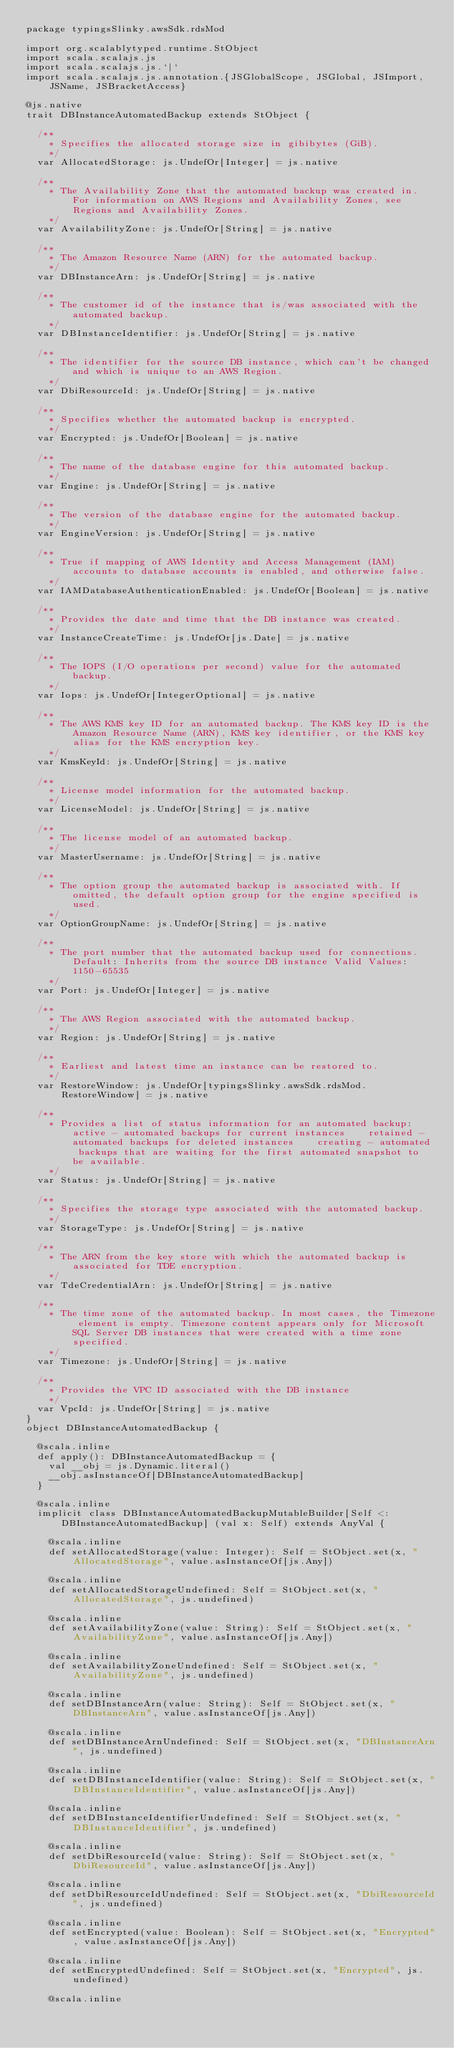<code> <loc_0><loc_0><loc_500><loc_500><_Scala_>package typingsSlinky.awsSdk.rdsMod

import org.scalablytyped.runtime.StObject
import scala.scalajs.js
import scala.scalajs.js.`|`
import scala.scalajs.js.annotation.{JSGlobalScope, JSGlobal, JSImport, JSName, JSBracketAccess}

@js.native
trait DBInstanceAutomatedBackup extends StObject {
  
  /**
    * Specifies the allocated storage size in gibibytes (GiB).
    */
  var AllocatedStorage: js.UndefOr[Integer] = js.native
  
  /**
    * The Availability Zone that the automated backup was created in. For information on AWS Regions and Availability Zones, see Regions and Availability Zones.
    */
  var AvailabilityZone: js.UndefOr[String] = js.native
  
  /**
    * The Amazon Resource Name (ARN) for the automated backup.
    */
  var DBInstanceArn: js.UndefOr[String] = js.native
  
  /**
    * The customer id of the instance that is/was associated with the automated backup. 
    */
  var DBInstanceIdentifier: js.UndefOr[String] = js.native
  
  /**
    * The identifier for the source DB instance, which can't be changed and which is unique to an AWS Region.
    */
  var DbiResourceId: js.UndefOr[String] = js.native
  
  /**
    * Specifies whether the automated backup is encrypted.
    */
  var Encrypted: js.UndefOr[Boolean] = js.native
  
  /**
    * The name of the database engine for this automated backup.
    */
  var Engine: js.UndefOr[String] = js.native
  
  /**
    * The version of the database engine for the automated backup.
    */
  var EngineVersion: js.UndefOr[String] = js.native
  
  /**
    * True if mapping of AWS Identity and Access Management (IAM) accounts to database accounts is enabled, and otherwise false.
    */
  var IAMDatabaseAuthenticationEnabled: js.UndefOr[Boolean] = js.native
  
  /**
    * Provides the date and time that the DB instance was created. 
    */
  var InstanceCreateTime: js.UndefOr[js.Date] = js.native
  
  /**
    * The IOPS (I/O operations per second) value for the automated backup. 
    */
  var Iops: js.UndefOr[IntegerOptional] = js.native
  
  /**
    * The AWS KMS key ID for an automated backup. The KMS key ID is the Amazon Resource Name (ARN), KMS key identifier, or the KMS key alias for the KMS encryption key. 
    */
  var KmsKeyId: js.UndefOr[String] = js.native
  
  /**
    * License model information for the automated backup.
    */
  var LicenseModel: js.UndefOr[String] = js.native
  
  /**
    * The license model of an automated backup.
    */
  var MasterUsername: js.UndefOr[String] = js.native
  
  /**
    * The option group the automated backup is associated with. If omitted, the default option group for the engine specified is used.
    */
  var OptionGroupName: js.UndefOr[String] = js.native
  
  /**
    * The port number that the automated backup used for connections. Default: Inherits from the source DB instance Valid Values: 1150-65535 
    */
  var Port: js.UndefOr[Integer] = js.native
  
  /**
    * The AWS Region associated with the automated backup.
    */
  var Region: js.UndefOr[String] = js.native
  
  /**
    * Earliest and latest time an instance can be restored to.
    */
  var RestoreWindow: js.UndefOr[typingsSlinky.awsSdk.rdsMod.RestoreWindow] = js.native
  
  /**
    * Provides a list of status information for an automated backup:    active - automated backups for current instances    retained - automated backups for deleted instances    creating - automated backups that are waiting for the first automated snapshot to be available.  
    */
  var Status: js.UndefOr[String] = js.native
  
  /**
    * Specifies the storage type associated with the automated backup.
    */
  var StorageType: js.UndefOr[String] = js.native
  
  /**
    * The ARN from the key store with which the automated backup is associated for TDE encryption.
    */
  var TdeCredentialArn: js.UndefOr[String] = js.native
  
  /**
    * The time zone of the automated backup. In most cases, the Timezone element is empty. Timezone content appears only for Microsoft SQL Server DB instances that were created with a time zone specified.
    */
  var Timezone: js.UndefOr[String] = js.native
  
  /**
    * Provides the VPC ID associated with the DB instance
    */
  var VpcId: js.UndefOr[String] = js.native
}
object DBInstanceAutomatedBackup {
  
  @scala.inline
  def apply(): DBInstanceAutomatedBackup = {
    val __obj = js.Dynamic.literal()
    __obj.asInstanceOf[DBInstanceAutomatedBackup]
  }
  
  @scala.inline
  implicit class DBInstanceAutomatedBackupMutableBuilder[Self <: DBInstanceAutomatedBackup] (val x: Self) extends AnyVal {
    
    @scala.inline
    def setAllocatedStorage(value: Integer): Self = StObject.set(x, "AllocatedStorage", value.asInstanceOf[js.Any])
    
    @scala.inline
    def setAllocatedStorageUndefined: Self = StObject.set(x, "AllocatedStorage", js.undefined)
    
    @scala.inline
    def setAvailabilityZone(value: String): Self = StObject.set(x, "AvailabilityZone", value.asInstanceOf[js.Any])
    
    @scala.inline
    def setAvailabilityZoneUndefined: Self = StObject.set(x, "AvailabilityZone", js.undefined)
    
    @scala.inline
    def setDBInstanceArn(value: String): Self = StObject.set(x, "DBInstanceArn", value.asInstanceOf[js.Any])
    
    @scala.inline
    def setDBInstanceArnUndefined: Self = StObject.set(x, "DBInstanceArn", js.undefined)
    
    @scala.inline
    def setDBInstanceIdentifier(value: String): Self = StObject.set(x, "DBInstanceIdentifier", value.asInstanceOf[js.Any])
    
    @scala.inline
    def setDBInstanceIdentifierUndefined: Self = StObject.set(x, "DBInstanceIdentifier", js.undefined)
    
    @scala.inline
    def setDbiResourceId(value: String): Self = StObject.set(x, "DbiResourceId", value.asInstanceOf[js.Any])
    
    @scala.inline
    def setDbiResourceIdUndefined: Self = StObject.set(x, "DbiResourceId", js.undefined)
    
    @scala.inline
    def setEncrypted(value: Boolean): Self = StObject.set(x, "Encrypted", value.asInstanceOf[js.Any])
    
    @scala.inline
    def setEncryptedUndefined: Self = StObject.set(x, "Encrypted", js.undefined)
    
    @scala.inline</code> 